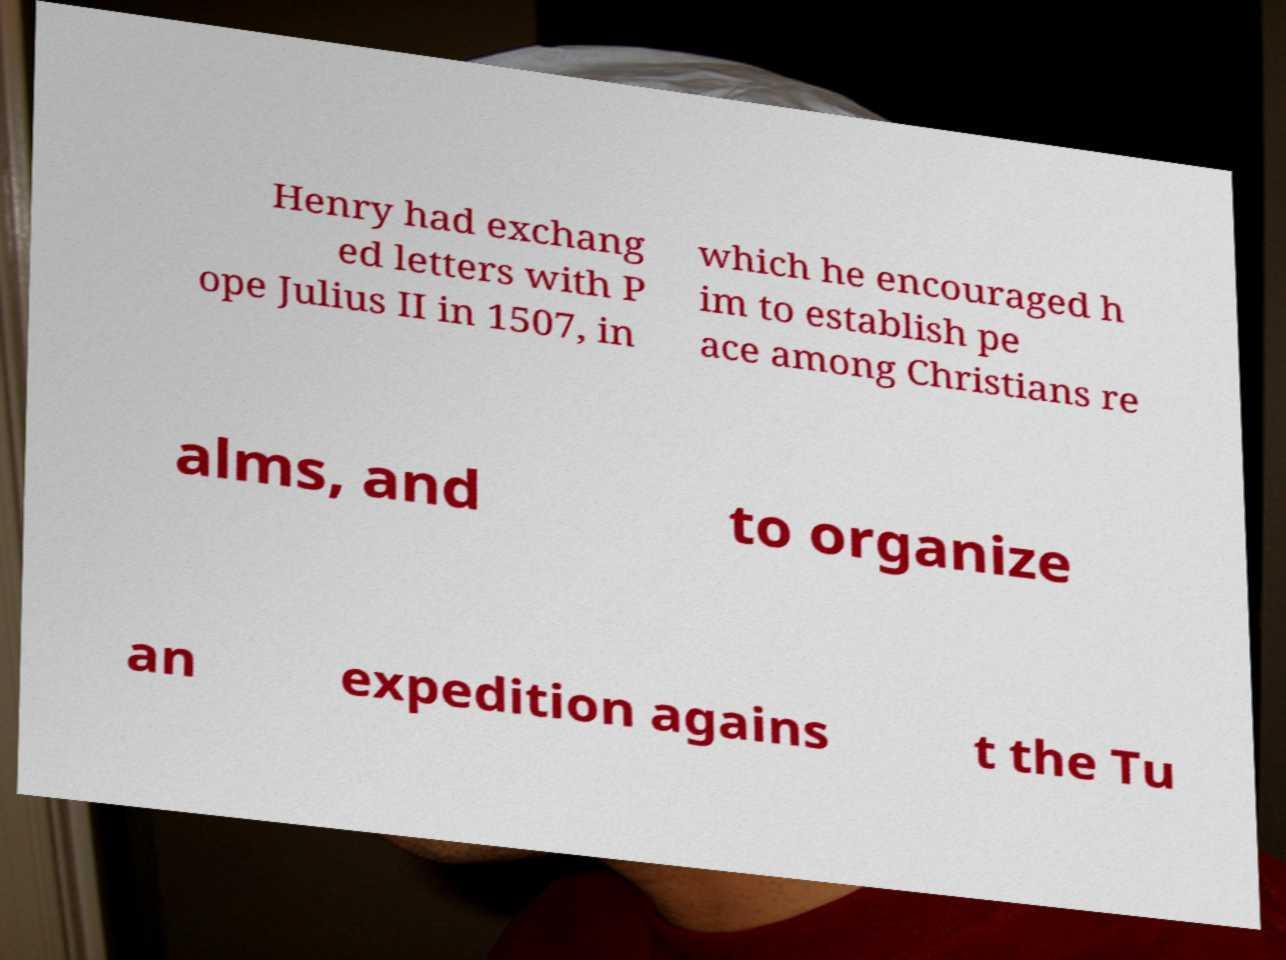Please read and relay the text visible in this image. What does it say? Henry had exchang ed letters with P ope Julius II in 1507, in which he encouraged h im to establish pe ace among Christians re alms, and to organize an expedition agains t the Tu 